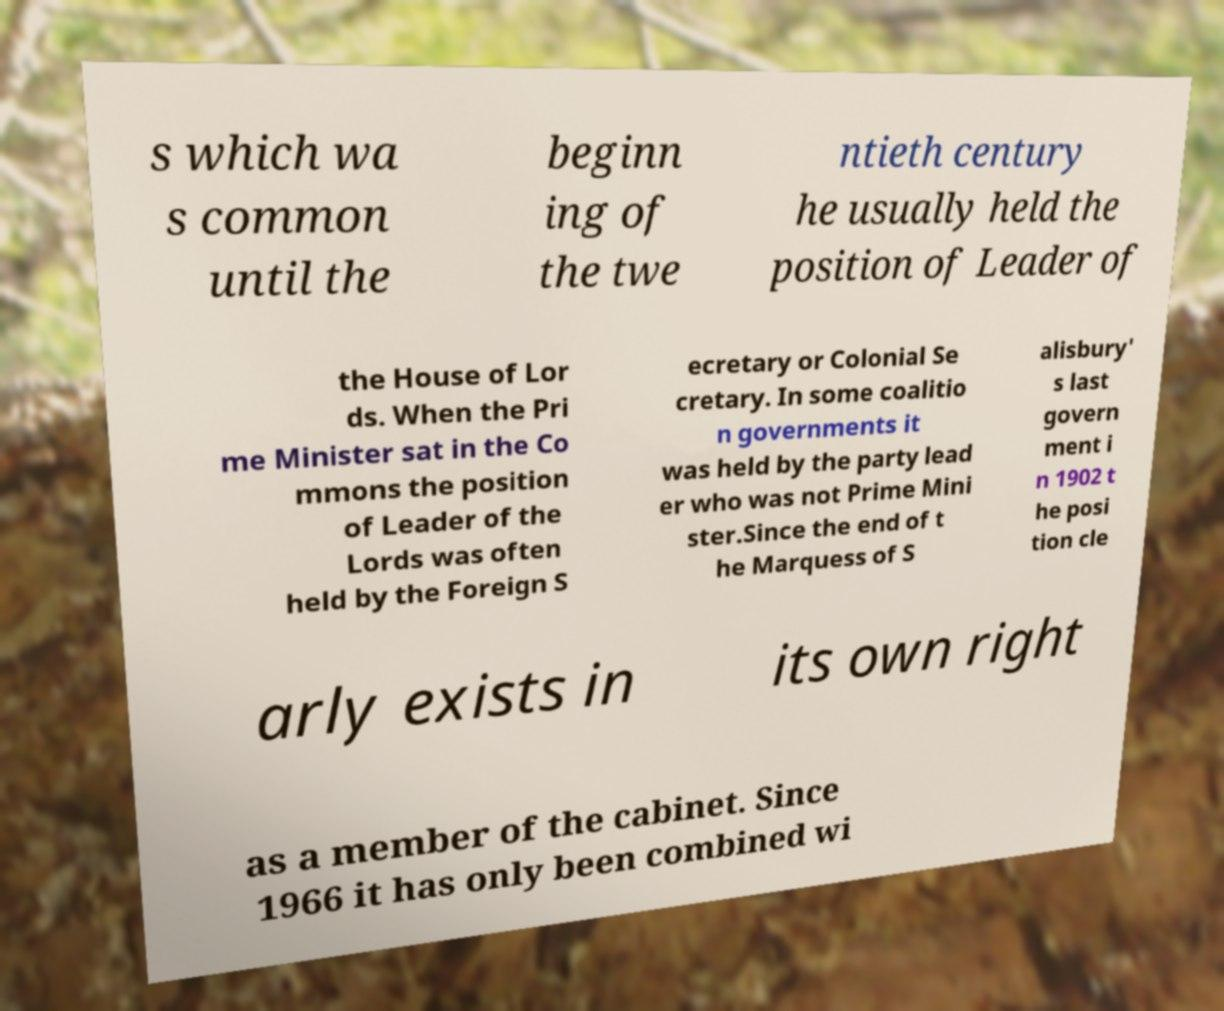I need the written content from this picture converted into text. Can you do that? s which wa s common until the beginn ing of the twe ntieth century he usually held the position of Leader of the House of Lor ds. When the Pri me Minister sat in the Co mmons the position of Leader of the Lords was often held by the Foreign S ecretary or Colonial Se cretary. In some coalitio n governments it was held by the party lead er who was not Prime Mini ster.Since the end of t he Marquess of S alisbury' s last govern ment i n 1902 t he posi tion cle arly exists in its own right as a member of the cabinet. Since 1966 it has only been combined wi 